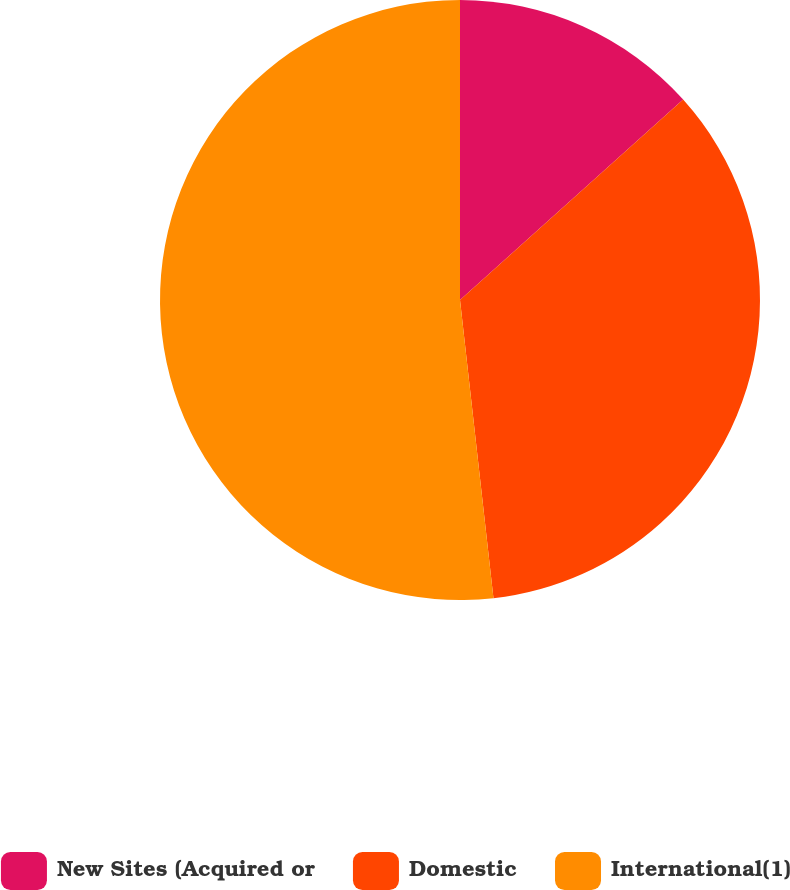Convert chart. <chart><loc_0><loc_0><loc_500><loc_500><pie_chart><fcel>New Sites (Acquired or<fcel>Domestic<fcel>International(1)<nl><fcel>13.35%<fcel>34.87%<fcel>51.78%<nl></chart> 